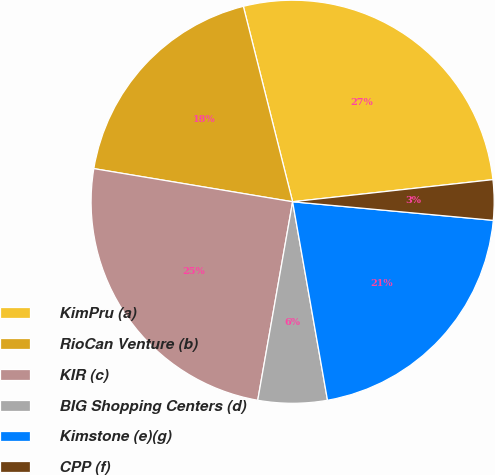Convert chart to OTSL. <chart><loc_0><loc_0><loc_500><loc_500><pie_chart><fcel>KimPru (a)<fcel>RioCan Venture (b)<fcel>KIR (c)<fcel>BIG Shopping Centers (d)<fcel>Kimstone (e)(g)<fcel>CPP (f)<nl><fcel>27.18%<fcel>18.44%<fcel>24.86%<fcel>5.54%<fcel>20.76%<fcel>3.22%<nl></chart> 